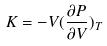Convert formula to latex. <formula><loc_0><loc_0><loc_500><loc_500>K = - V ( \frac { \partial P } { \partial V } ) _ { T }</formula> 